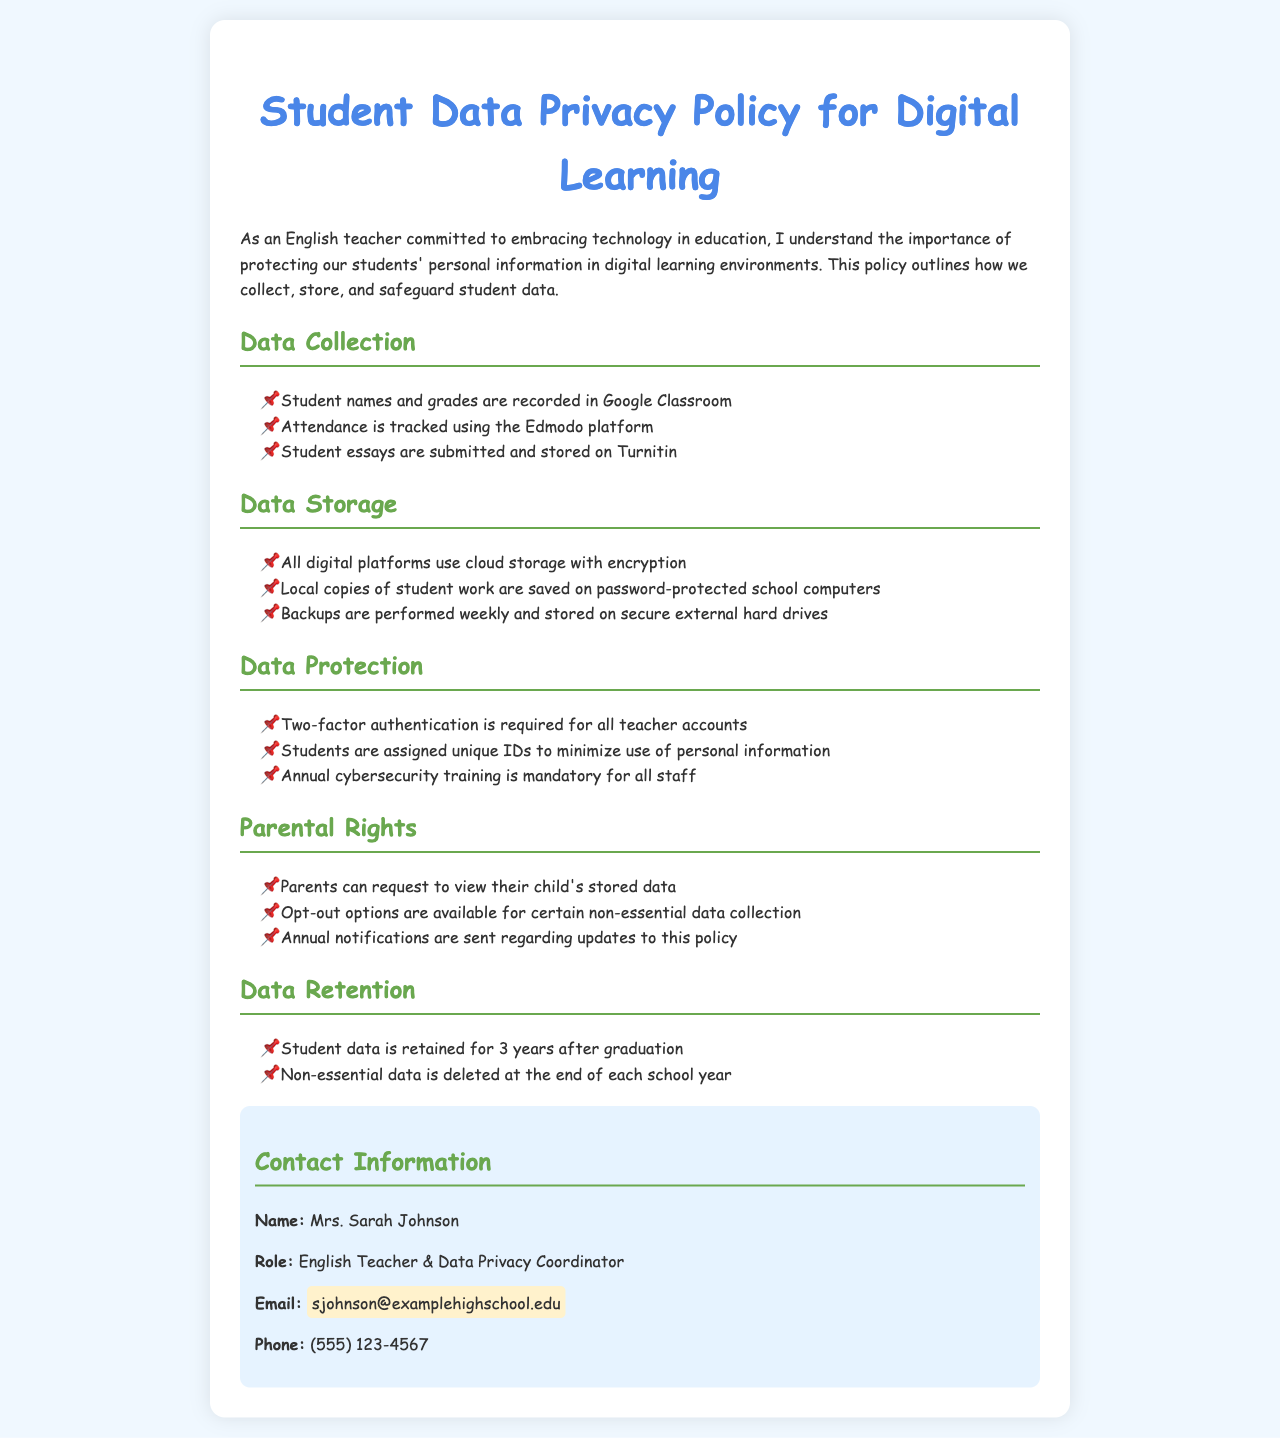What are the platforms used for data collection? The document lists Google Classroom, Edmodo, and Turnitin as the platforms for recording student names, tracking attendance, and storing essays, respectively.
Answer: Google Classroom, Edmodo, Turnitin How long is student data retained after graduation? The document states that student data is retained for a specified period after graduation, which is 3 years.
Answer: 3 years What security measure is required for teacher accounts? The policy specifies that two-factor authentication is a necessary security measure for all teacher accounts.
Answer: Two-factor authentication Who can parents contact for questions about data privacy? The document provides specific contact information for the Data Privacy Coordinator, which is Mrs. Sarah Johnson.
Answer: Mrs. Sarah Johnson What is done with non-essential data at the end of each school year? The policy states that non-essential data is deleted at the end of each school year.
Answer: Deleted What unique identification method is used for students? The document mentions that students are assigned unique IDs to help protect their personal information.
Answer: Unique IDs 